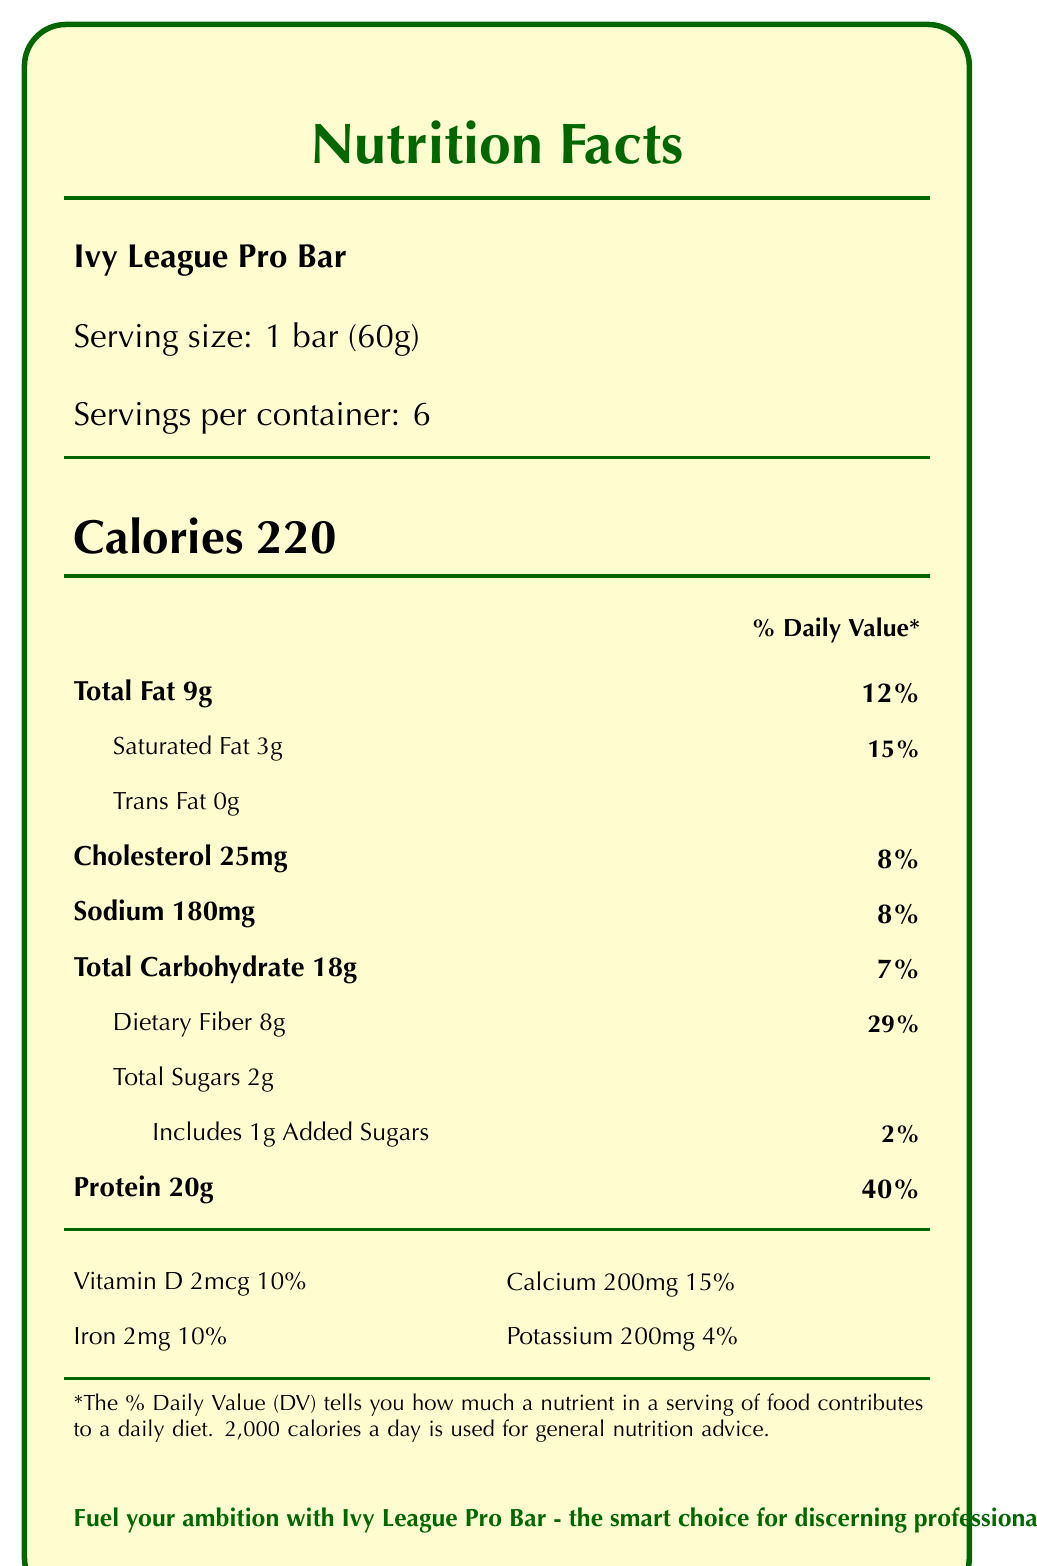what is the serving size for the Ivy League Pro Bar? The serving size is stated directly on the document as "Serving size: 1 bar (60g)".
Answer: 1 bar (60g) how many calories are in one bar? The document states "Calories 220" quite prominently.
Answer: 220 what is the total fat content per serving? The document lists "Total Fat 9g".
Answer: 9g how much dietary fiber is in one bar? The document specifies "Dietary Fiber 8g".
Answer: 8g what allergens are present in the Ivy League Pro Bar? This is mentioned under the allergens section of the document.
Answer: Contains milk and tree nuts (almonds); Manufactured in a facility that also processes soy, peanuts, and other tree nuts how much protein does each bar contain? The document states "Protein 20g" under the nutrition facts.
Answer: 20g what percent of the daily value for calcium does one bar provide? The document states "Calcium 200mg 15%" under the vitamin and mineral information.
Answer: 15% how many grams of added sugar are in one bar? The document lists "Includes 1g Added Sugars".
Answer: 1g how much sodium is in one bar? The document specifies "Sodium 180mg".
Answer: 180mg which of the following ingredients is not listed in the Ivy League Pro Bar? A. Almonds B. Pea protein crisps C. Cocoa butter D. Brown rice syrup The ingredients section lists Almonds, Pea protein crisps, and Cocoa butter, but Brown rice syrup is not listed.
Answer: D what is the brand statement for the Ivy League Pro Bar? A. Energy for everyone B. Fuel your ambition with Ivy League Pro Bar - the smart choice for discerning professionals C. High protein, low carb D. The best nutrition bar for students and academics The document states "Fuel your ambition with Ivy League Pro Bar - the smart choice for discerning professionals".
Answer: B is the Ivy League Pro Bar gluten-free? The document lists "Gluten-Free Certified" under certifications.
Answer: Yes summarize the main nutritional aspects of the Ivy League Pro Bar. This summary includes key information about calories, macronutrient content, and certifications mentioned in the document.
Answer: The Ivy League Pro Bar has 220 calories per serving, with 20g of protein, 9g of total fat, 8g of dietary fiber, and only 2g of total sugars. It is high in protein and fiber while being low in sugar, making it suitable for busy professionals seeking a nutritious and convenient snack. It also has several certifications, indicating it's non-GMO and gluten-free. can you determine the expiration date of the Ivy League Pro Bar from the document? The document mentions "Best if consumed by date on package," but does not provide an actual expiration date.
Answer: Not enough information 